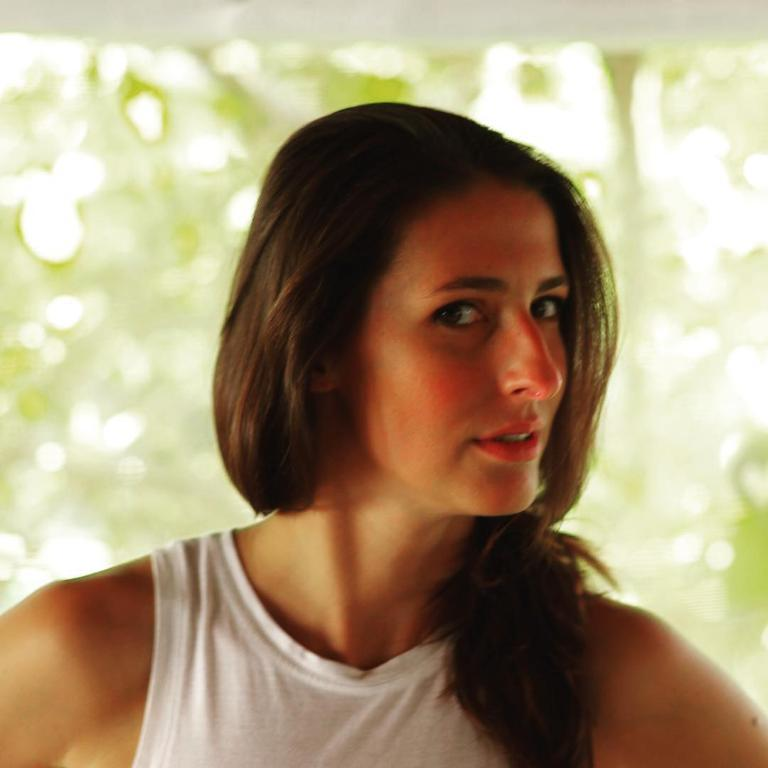What is the main subject of the image? The main subject of the image is a beautiful woman. What is the woman doing in the image? The woman is looking at the side. What color is the top that the woman is wearing? The woman is wearing a white color top. What time of day is it in the image, considering the woman is taking a bath? There is no indication in the image that the woman is taking a bath, and therefore we cannot determine the time of day. 